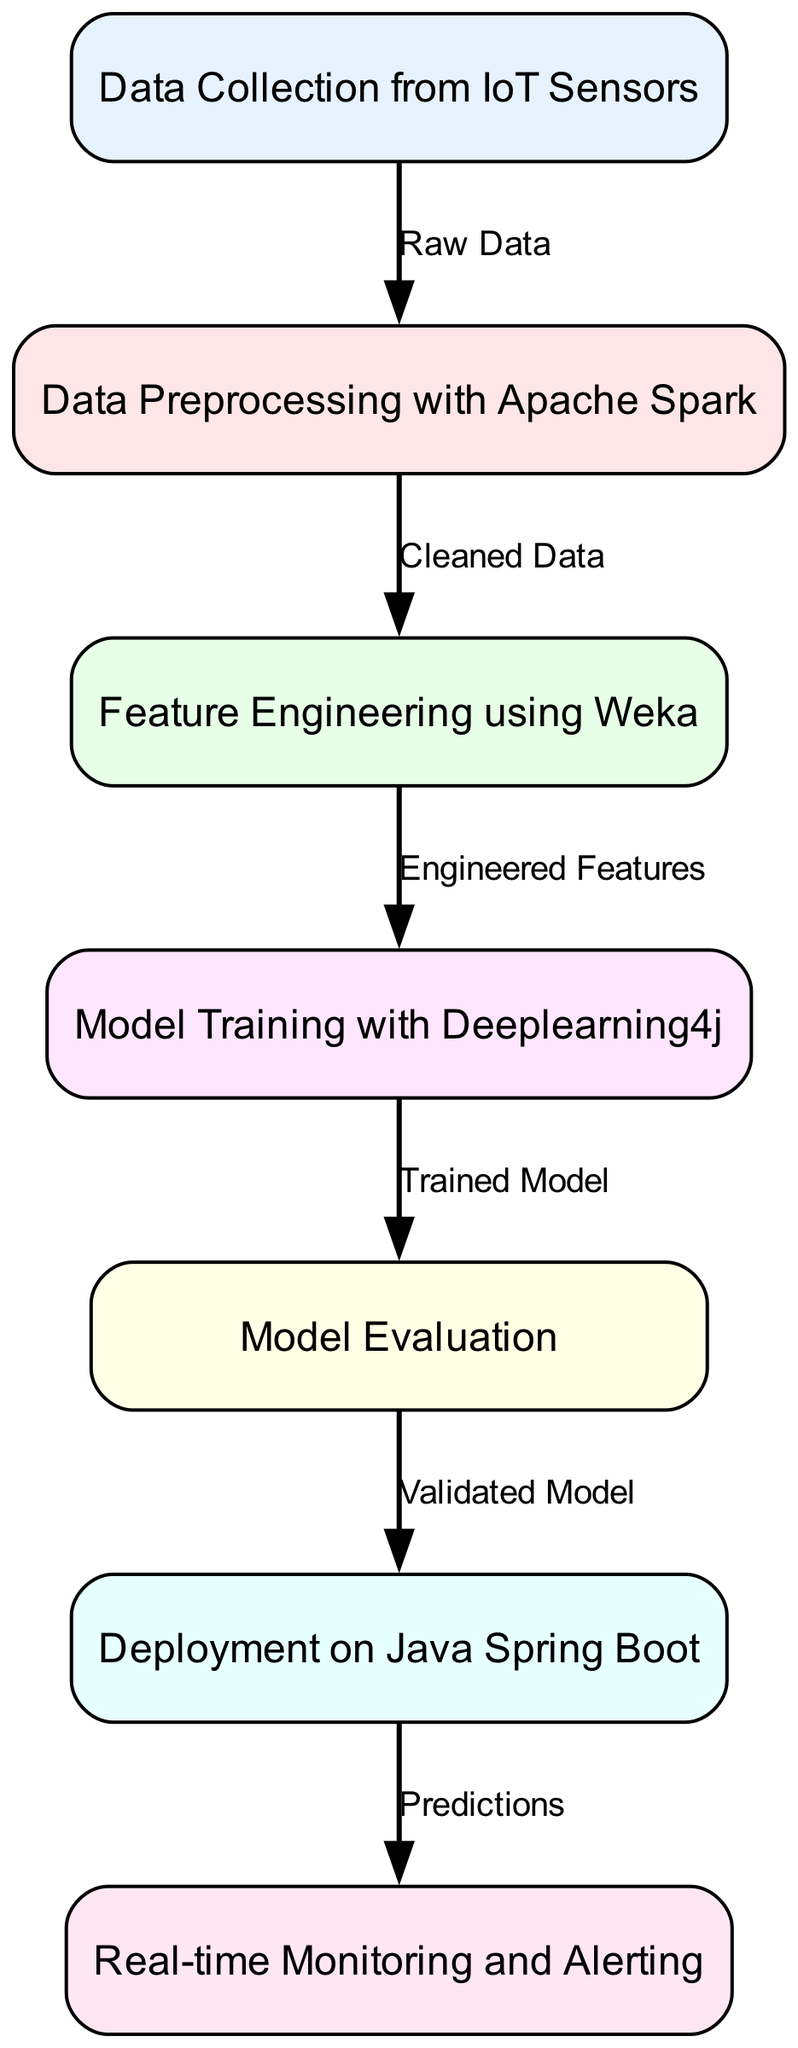What is the first step in the machine learning pipeline? The first step is represented by the node "Data Collection from IoT Sensors". This node indicates that the initial action in the pipeline is to gather data from IoT sensors, making it the starting point.
Answer: Data Collection from IoT Sensors How many nodes are in the diagram? By counting the number of distinct operational steps outlined in the nodes, we find there are a total of six nodes in the pipeline.
Answer: Six What type of data flows from data preprocessing to feature engineering? The edge connecting these two nodes is labeled "Cleaned Data", which shows that the data being passed from data preprocessing to feature engineering is cleaned and ready for further enhancement.
Answer: Cleaned Data Which node follows model training? The node that follows model training is "Model Evaluation". This can be seen directly from the edge connection that indicates the flow from model training to model evaluation.
Answer: Model Evaluation What is the last step in the machine learning pipeline? The last step is "Real-time Monitoring and Alerting". This indicates that after deployment, the process culminates in monitoring the system in real-time.
Answer: Real-time Monitoring and Alerting What is the relationship between model evaluation and deployment? The edge connecting these nodes is labeled "Validated Model", indicating that a validated model, resulting from model evaluation, is necessary for deployment.
Answer: Validated Model 